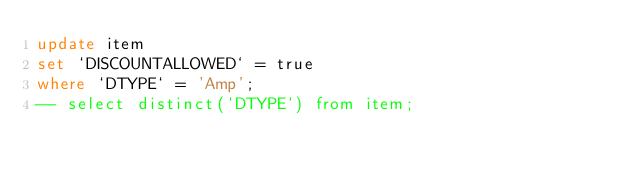<code> <loc_0><loc_0><loc_500><loc_500><_SQL_>update item
set `DISCOUNTALLOWED` = true
where `DTYPE` = 'Amp';
-- select distinct(`DTYPE`) from item;</code> 